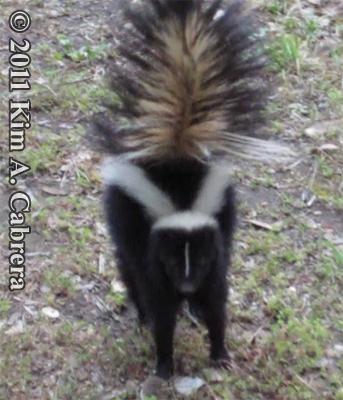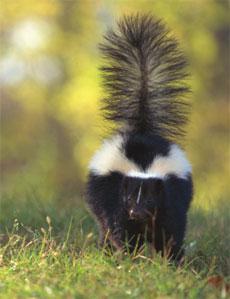The first image is the image on the left, the second image is the image on the right. Given the left and right images, does the statement "Both skunks are on the ground." hold true? Answer yes or no. Yes. The first image is the image on the left, the second image is the image on the right. Evaluate the accuracy of this statement regarding the images: "Each image contains one skunk with its tail raised, and at least one image features a skunk with its body, tail and head facing directly forward.". Is it true? Answer yes or no. Yes. 